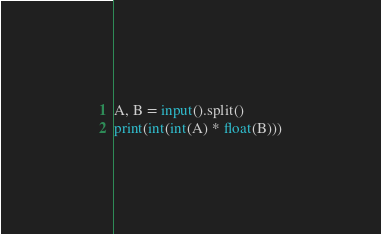<code> <loc_0><loc_0><loc_500><loc_500><_Python_>A, B = input().split()
print(int(int(A) * float(B)))
</code> 